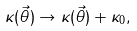Convert formula to latex. <formula><loc_0><loc_0><loc_500><loc_500>\kappa ( \vec { \theta } ) \to \kappa ( \vec { \theta } ) + \kappa _ { 0 } ,</formula> 